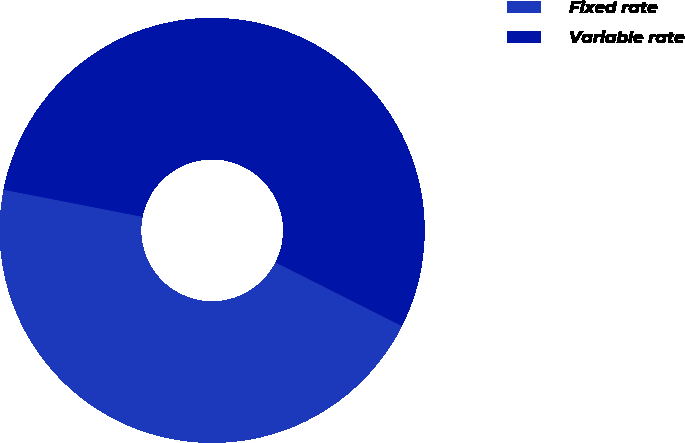<chart> <loc_0><loc_0><loc_500><loc_500><pie_chart><fcel>Fixed rate<fcel>Variable rate<nl><fcel>45.64%<fcel>54.36%<nl></chart> 